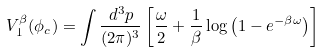Convert formula to latex. <formula><loc_0><loc_0><loc_500><loc_500>V _ { 1 } ^ { \beta } ( \phi _ { c } ) = \int \frac { d ^ { 3 } p } { ( 2 \pi ) ^ { 3 } } \left [ \frac { \omega } { 2 } + \frac { 1 } { \beta } \log \left ( 1 - e ^ { - \beta \omega } \right ) \right ]</formula> 